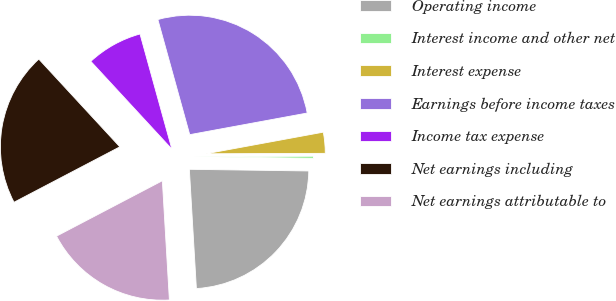<chart> <loc_0><loc_0><loc_500><loc_500><pie_chart><fcel>Operating income<fcel>Interest income and other net<fcel>Interest expense<fcel>Earnings before income taxes<fcel>Income tax expense<fcel>Net earnings including<fcel>Net earnings attributable to<nl><fcel>23.84%<fcel>0.28%<fcel>2.84%<fcel>26.4%<fcel>7.57%<fcel>20.81%<fcel>18.26%<nl></chart> 